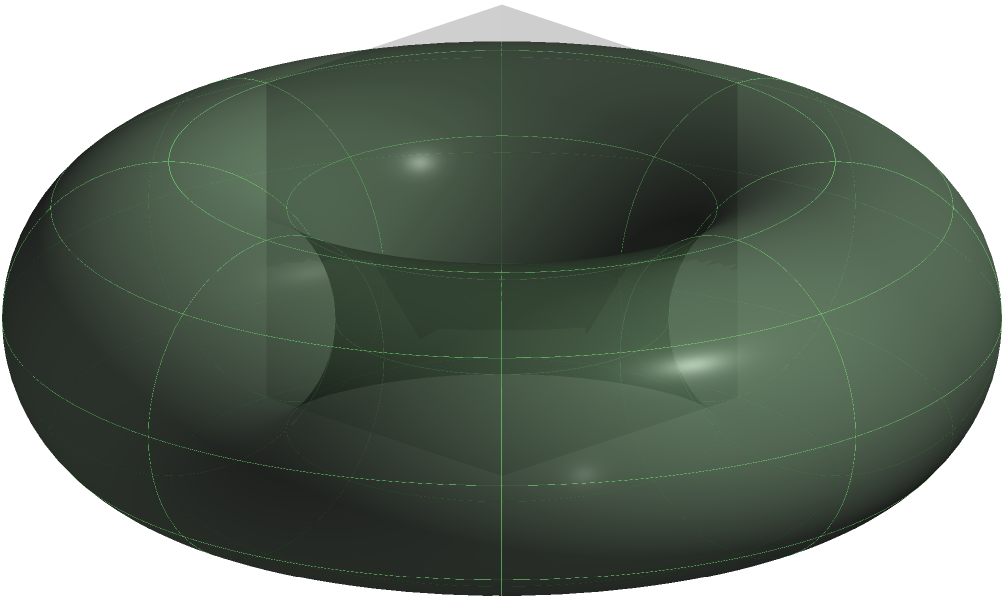As a botany professor, you're exploring the topology of plant structures. Consider the surface shown in the image, which represents a simplified model of a specialized leaf structure. What is the genus of this surface, and is it orientable? How might this relate to the adaptability of plants in different environments? Let's approach this step-by-step:

1. Surface identification: The surface shown is a torus, also known as a donut shape.

2. Genus calculation:
   - The genus of a surface is the number of "holes" it has.
   - A torus has one hole, so its genus is 1.

3. Orientability:
   - A surface is orientable if it has two distinct sides.
   - We can continuously move a normal vector around the entire surface without it ever flipping direction.
   - The torus is orientable because it has a well-defined "inside" and "outside."

4. Relation to plant structures:
   - In botany, toroidal structures can be found in certain cellular organelles or in the arrangement of vascular tissues.
   - The genus and orientability of plant structures can influence their function:
     a) The genus (number of holes) can affect the surface area to volume ratio, which is crucial for processes like gas exchange or nutrient absorption.
     b) Orientability ensures consistent directionality in processes like fluid transport or signal transmission.

5. Adaptability in different environments:
   - The topological properties of plant structures can contribute to their adaptability:
     a) A higher genus (more holes) could increase surface area for more efficient resource uptake in resource-poor environments.
     b) Orientable surfaces might allow for more organized and directed growth patterns, potentially beneficial in competitive environments.

In conclusion, the surface is a torus with genus 1, and it is orientable. These properties could relate to efficient resource utilization and organized growth in plants, contributing to their adaptability in various environments.
Answer: Genus: 1, Orientable 